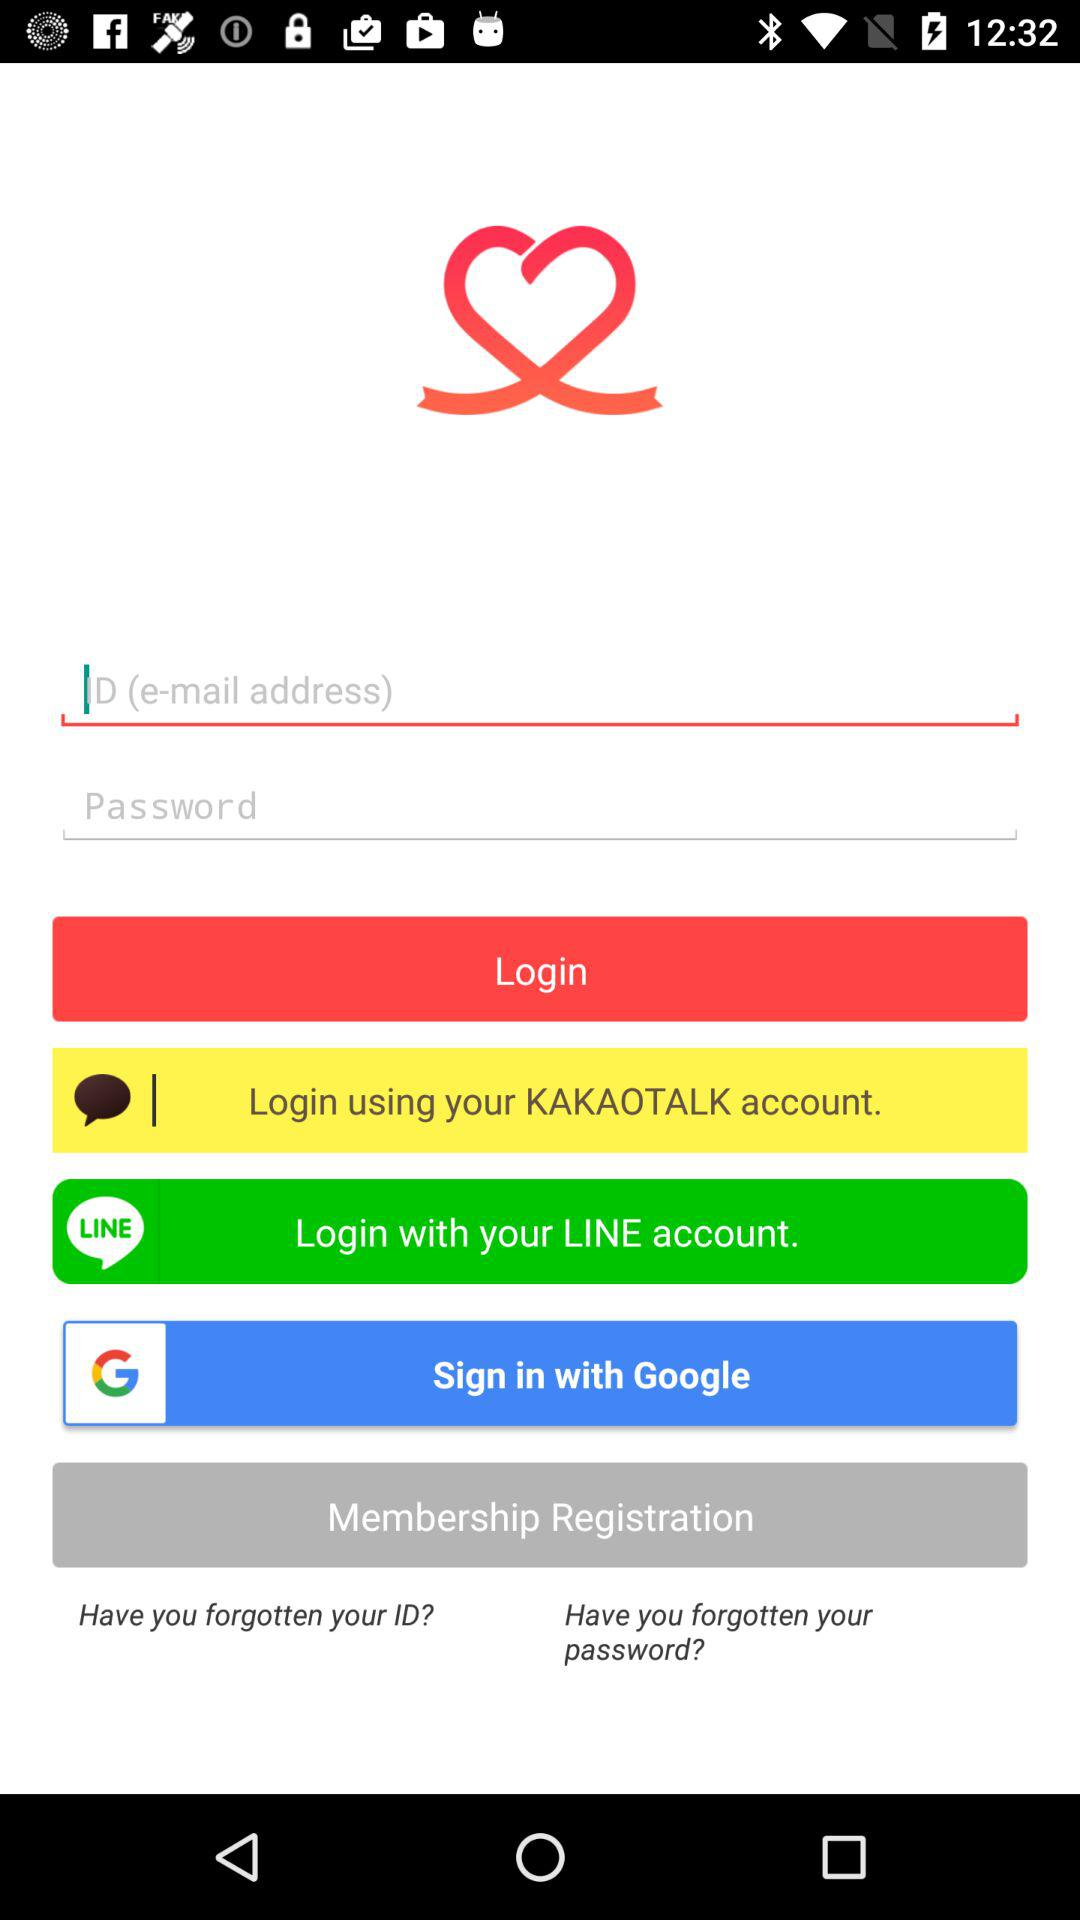What is the Email address?
When the provided information is insufficient, respond with <no answer>. <no answer> 